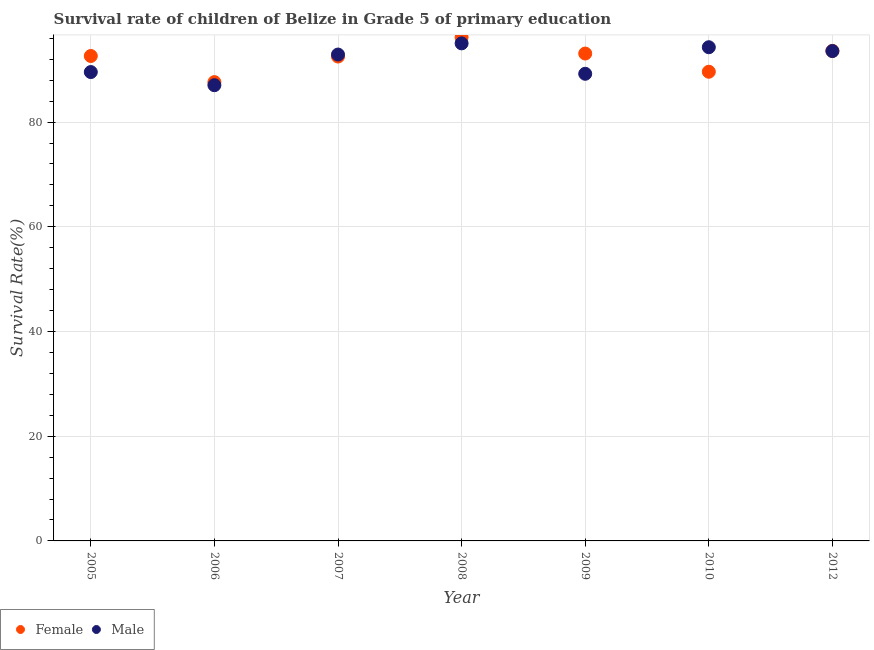Is the number of dotlines equal to the number of legend labels?
Keep it short and to the point. Yes. What is the survival rate of female students in primary education in 2005?
Provide a succinct answer. 92.62. Across all years, what is the maximum survival rate of male students in primary education?
Ensure brevity in your answer.  95.03. Across all years, what is the minimum survival rate of male students in primary education?
Provide a short and direct response. 87.04. In which year was the survival rate of female students in primary education minimum?
Provide a succinct answer. 2006. What is the total survival rate of male students in primary education in the graph?
Your answer should be very brief. 641.59. What is the difference between the survival rate of male students in primary education in 2005 and that in 2010?
Provide a succinct answer. -4.74. What is the difference between the survival rate of female students in primary education in 2005 and the survival rate of male students in primary education in 2009?
Provide a succinct answer. 3.4. What is the average survival rate of female students in primary education per year?
Keep it short and to the point. 92.18. In the year 2005, what is the difference between the survival rate of male students in primary education and survival rate of female students in primary education?
Give a very brief answer. -3.07. In how many years, is the survival rate of male students in primary education greater than 80 %?
Offer a terse response. 7. What is the ratio of the survival rate of female students in primary education in 2007 to that in 2012?
Make the answer very short. 0.99. Is the survival rate of female students in primary education in 2008 less than that in 2010?
Provide a short and direct response. No. Is the difference between the survival rate of female students in primary education in 2005 and 2010 greater than the difference between the survival rate of male students in primary education in 2005 and 2010?
Provide a short and direct response. Yes. What is the difference between the highest and the second highest survival rate of female students in primary education?
Provide a short and direct response. 2.6. What is the difference between the highest and the lowest survival rate of male students in primary education?
Provide a short and direct response. 7.99. In how many years, is the survival rate of female students in primary education greater than the average survival rate of female students in primary education taken over all years?
Ensure brevity in your answer.  5. Is the sum of the survival rate of female students in primary education in 2005 and 2009 greater than the maximum survival rate of male students in primary education across all years?
Offer a terse response. Yes. Does the survival rate of male students in primary education monotonically increase over the years?
Your answer should be compact. No. Is the survival rate of male students in primary education strictly greater than the survival rate of female students in primary education over the years?
Provide a short and direct response. No. How many dotlines are there?
Provide a succinct answer. 2. How many years are there in the graph?
Ensure brevity in your answer.  7. Where does the legend appear in the graph?
Your response must be concise. Bottom left. How many legend labels are there?
Provide a succinct answer. 2. What is the title of the graph?
Your answer should be very brief. Survival rate of children of Belize in Grade 5 of primary education. Does "Money lenders" appear as one of the legend labels in the graph?
Your response must be concise. No. What is the label or title of the X-axis?
Offer a terse response. Year. What is the label or title of the Y-axis?
Make the answer very short. Survival Rate(%). What is the Survival Rate(%) in Female in 2005?
Keep it short and to the point. 92.62. What is the Survival Rate(%) in Male in 2005?
Provide a succinct answer. 89.55. What is the Survival Rate(%) in Female in 2006?
Make the answer very short. 87.63. What is the Survival Rate(%) of Male in 2006?
Your answer should be compact. 87.04. What is the Survival Rate(%) in Female in 2007?
Provide a short and direct response. 92.51. What is the Survival Rate(%) of Male in 2007?
Your answer should be compact. 92.9. What is the Survival Rate(%) of Female in 2008?
Your answer should be very brief. 96.19. What is the Survival Rate(%) in Male in 2008?
Offer a very short reply. 95.03. What is the Survival Rate(%) of Female in 2009?
Your answer should be compact. 93.09. What is the Survival Rate(%) of Male in 2009?
Offer a very short reply. 89.22. What is the Survival Rate(%) of Female in 2010?
Your response must be concise. 89.61. What is the Survival Rate(%) in Male in 2010?
Offer a terse response. 94.29. What is the Survival Rate(%) in Female in 2012?
Give a very brief answer. 93.59. What is the Survival Rate(%) in Male in 2012?
Keep it short and to the point. 93.56. Across all years, what is the maximum Survival Rate(%) in Female?
Give a very brief answer. 96.19. Across all years, what is the maximum Survival Rate(%) of Male?
Your answer should be very brief. 95.03. Across all years, what is the minimum Survival Rate(%) in Female?
Offer a very short reply. 87.63. Across all years, what is the minimum Survival Rate(%) of Male?
Your answer should be very brief. 87.04. What is the total Survival Rate(%) in Female in the graph?
Provide a short and direct response. 645.24. What is the total Survival Rate(%) in Male in the graph?
Offer a terse response. 641.59. What is the difference between the Survival Rate(%) in Female in 2005 and that in 2006?
Offer a very short reply. 4.99. What is the difference between the Survival Rate(%) of Male in 2005 and that in 2006?
Keep it short and to the point. 2.51. What is the difference between the Survival Rate(%) in Female in 2005 and that in 2007?
Your answer should be compact. 0.1. What is the difference between the Survival Rate(%) of Male in 2005 and that in 2007?
Offer a terse response. -3.35. What is the difference between the Survival Rate(%) of Female in 2005 and that in 2008?
Your response must be concise. -3.58. What is the difference between the Survival Rate(%) of Male in 2005 and that in 2008?
Offer a terse response. -5.48. What is the difference between the Survival Rate(%) of Female in 2005 and that in 2009?
Give a very brief answer. -0.47. What is the difference between the Survival Rate(%) in Male in 2005 and that in 2009?
Offer a terse response. 0.33. What is the difference between the Survival Rate(%) in Female in 2005 and that in 2010?
Give a very brief answer. 3.01. What is the difference between the Survival Rate(%) in Male in 2005 and that in 2010?
Give a very brief answer. -4.74. What is the difference between the Survival Rate(%) in Female in 2005 and that in 2012?
Offer a very short reply. -0.97. What is the difference between the Survival Rate(%) of Male in 2005 and that in 2012?
Keep it short and to the point. -4.01. What is the difference between the Survival Rate(%) of Female in 2006 and that in 2007?
Offer a very short reply. -4.89. What is the difference between the Survival Rate(%) of Male in 2006 and that in 2007?
Provide a succinct answer. -5.85. What is the difference between the Survival Rate(%) in Female in 2006 and that in 2008?
Your answer should be compact. -8.56. What is the difference between the Survival Rate(%) of Male in 2006 and that in 2008?
Your answer should be compact. -7.99. What is the difference between the Survival Rate(%) in Female in 2006 and that in 2009?
Offer a very short reply. -5.46. What is the difference between the Survival Rate(%) of Male in 2006 and that in 2009?
Make the answer very short. -2.18. What is the difference between the Survival Rate(%) of Female in 2006 and that in 2010?
Offer a very short reply. -1.98. What is the difference between the Survival Rate(%) of Male in 2006 and that in 2010?
Offer a very short reply. -7.25. What is the difference between the Survival Rate(%) in Female in 2006 and that in 2012?
Your answer should be compact. -5.96. What is the difference between the Survival Rate(%) of Male in 2006 and that in 2012?
Ensure brevity in your answer.  -6.52. What is the difference between the Survival Rate(%) of Female in 2007 and that in 2008?
Provide a succinct answer. -3.68. What is the difference between the Survival Rate(%) in Male in 2007 and that in 2008?
Offer a very short reply. -2.13. What is the difference between the Survival Rate(%) of Female in 2007 and that in 2009?
Give a very brief answer. -0.57. What is the difference between the Survival Rate(%) in Male in 2007 and that in 2009?
Your answer should be very brief. 3.68. What is the difference between the Survival Rate(%) of Female in 2007 and that in 2010?
Your response must be concise. 2.91. What is the difference between the Survival Rate(%) of Male in 2007 and that in 2010?
Offer a very short reply. -1.4. What is the difference between the Survival Rate(%) in Female in 2007 and that in 2012?
Your answer should be very brief. -1.08. What is the difference between the Survival Rate(%) of Male in 2007 and that in 2012?
Keep it short and to the point. -0.67. What is the difference between the Survival Rate(%) in Female in 2008 and that in 2009?
Provide a short and direct response. 3.11. What is the difference between the Survival Rate(%) of Male in 2008 and that in 2009?
Provide a succinct answer. 5.81. What is the difference between the Survival Rate(%) of Female in 2008 and that in 2010?
Ensure brevity in your answer.  6.58. What is the difference between the Survival Rate(%) of Male in 2008 and that in 2010?
Provide a short and direct response. 0.74. What is the difference between the Survival Rate(%) in Female in 2008 and that in 2012?
Offer a very short reply. 2.6. What is the difference between the Survival Rate(%) in Male in 2008 and that in 2012?
Your answer should be compact. 1.47. What is the difference between the Survival Rate(%) in Female in 2009 and that in 2010?
Your answer should be very brief. 3.48. What is the difference between the Survival Rate(%) in Male in 2009 and that in 2010?
Your response must be concise. -5.07. What is the difference between the Survival Rate(%) in Female in 2009 and that in 2012?
Ensure brevity in your answer.  -0.5. What is the difference between the Survival Rate(%) in Male in 2009 and that in 2012?
Keep it short and to the point. -4.34. What is the difference between the Survival Rate(%) in Female in 2010 and that in 2012?
Offer a terse response. -3.98. What is the difference between the Survival Rate(%) in Male in 2010 and that in 2012?
Make the answer very short. 0.73. What is the difference between the Survival Rate(%) of Female in 2005 and the Survival Rate(%) of Male in 2006?
Keep it short and to the point. 5.58. What is the difference between the Survival Rate(%) in Female in 2005 and the Survival Rate(%) in Male in 2007?
Make the answer very short. -0.28. What is the difference between the Survival Rate(%) of Female in 2005 and the Survival Rate(%) of Male in 2008?
Provide a succinct answer. -2.41. What is the difference between the Survival Rate(%) of Female in 2005 and the Survival Rate(%) of Male in 2009?
Offer a very short reply. 3.4. What is the difference between the Survival Rate(%) in Female in 2005 and the Survival Rate(%) in Male in 2010?
Provide a short and direct response. -1.67. What is the difference between the Survival Rate(%) in Female in 2005 and the Survival Rate(%) in Male in 2012?
Offer a terse response. -0.94. What is the difference between the Survival Rate(%) in Female in 2006 and the Survival Rate(%) in Male in 2007?
Your answer should be very brief. -5.27. What is the difference between the Survival Rate(%) in Female in 2006 and the Survival Rate(%) in Male in 2008?
Provide a short and direct response. -7.4. What is the difference between the Survival Rate(%) in Female in 2006 and the Survival Rate(%) in Male in 2009?
Your response must be concise. -1.59. What is the difference between the Survival Rate(%) of Female in 2006 and the Survival Rate(%) of Male in 2010?
Provide a succinct answer. -6.66. What is the difference between the Survival Rate(%) in Female in 2006 and the Survival Rate(%) in Male in 2012?
Provide a short and direct response. -5.93. What is the difference between the Survival Rate(%) of Female in 2007 and the Survival Rate(%) of Male in 2008?
Your response must be concise. -2.52. What is the difference between the Survival Rate(%) of Female in 2007 and the Survival Rate(%) of Male in 2009?
Provide a short and direct response. 3.29. What is the difference between the Survival Rate(%) in Female in 2007 and the Survival Rate(%) in Male in 2010?
Provide a short and direct response. -1.78. What is the difference between the Survival Rate(%) of Female in 2007 and the Survival Rate(%) of Male in 2012?
Your response must be concise. -1.05. What is the difference between the Survival Rate(%) in Female in 2008 and the Survival Rate(%) in Male in 2009?
Your response must be concise. 6.97. What is the difference between the Survival Rate(%) in Female in 2008 and the Survival Rate(%) in Male in 2010?
Make the answer very short. 1.9. What is the difference between the Survival Rate(%) of Female in 2008 and the Survival Rate(%) of Male in 2012?
Offer a very short reply. 2.63. What is the difference between the Survival Rate(%) in Female in 2009 and the Survival Rate(%) in Male in 2010?
Offer a very short reply. -1.2. What is the difference between the Survival Rate(%) of Female in 2009 and the Survival Rate(%) of Male in 2012?
Provide a succinct answer. -0.47. What is the difference between the Survival Rate(%) in Female in 2010 and the Survival Rate(%) in Male in 2012?
Ensure brevity in your answer.  -3.95. What is the average Survival Rate(%) in Female per year?
Offer a very short reply. 92.18. What is the average Survival Rate(%) of Male per year?
Give a very brief answer. 91.66. In the year 2005, what is the difference between the Survival Rate(%) in Female and Survival Rate(%) in Male?
Your response must be concise. 3.07. In the year 2006, what is the difference between the Survival Rate(%) in Female and Survival Rate(%) in Male?
Your answer should be compact. 0.59. In the year 2007, what is the difference between the Survival Rate(%) in Female and Survival Rate(%) in Male?
Offer a terse response. -0.38. In the year 2008, what is the difference between the Survival Rate(%) in Female and Survival Rate(%) in Male?
Keep it short and to the point. 1.16. In the year 2009, what is the difference between the Survival Rate(%) in Female and Survival Rate(%) in Male?
Your response must be concise. 3.87. In the year 2010, what is the difference between the Survival Rate(%) of Female and Survival Rate(%) of Male?
Give a very brief answer. -4.68. In the year 2012, what is the difference between the Survival Rate(%) of Female and Survival Rate(%) of Male?
Your response must be concise. 0.03. What is the ratio of the Survival Rate(%) of Female in 2005 to that in 2006?
Keep it short and to the point. 1.06. What is the ratio of the Survival Rate(%) of Male in 2005 to that in 2006?
Your response must be concise. 1.03. What is the ratio of the Survival Rate(%) of Male in 2005 to that in 2007?
Make the answer very short. 0.96. What is the ratio of the Survival Rate(%) of Female in 2005 to that in 2008?
Give a very brief answer. 0.96. What is the ratio of the Survival Rate(%) in Male in 2005 to that in 2008?
Offer a very short reply. 0.94. What is the ratio of the Survival Rate(%) in Female in 2005 to that in 2010?
Your answer should be very brief. 1.03. What is the ratio of the Survival Rate(%) in Male in 2005 to that in 2010?
Your answer should be compact. 0.95. What is the ratio of the Survival Rate(%) in Male in 2005 to that in 2012?
Provide a succinct answer. 0.96. What is the ratio of the Survival Rate(%) in Female in 2006 to that in 2007?
Offer a very short reply. 0.95. What is the ratio of the Survival Rate(%) in Male in 2006 to that in 2007?
Your response must be concise. 0.94. What is the ratio of the Survival Rate(%) in Female in 2006 to that in 2008?
Give a very brief answer. 0.91. What is the ratio of the Survival Rate(%) in Male in 2006 to that in 2008?
Keep it short and to the point. 0.92. What is the ratio of the Survival Rate(%) in Female in 2006 to that in 2009?
Keep it short and to the point. 0.94. What is the ratio of the Survival Rate(%) of Male in 2006 to that in 2009?
Provide a short and direct response. 0.98. What is the ratio of the Survival Rate(%) of Female in 2006 to that in 2010?
Your response must be concise. 0.98. What is the ratio of the Survival Rate(%) of Female in 2006 to that in 2012?
Provide a short and direct response. 0.94. What is the ratio of the Survival Rate(%) in Male in 2006 to that in 2012?
Keep it short and to the point. 0.93. What is the ratio of the Survival Rate(%) in Female in 2007 to that in 2008?
Keep it short and to the point. 0.96. What is the ratio of the Survival Rate(%) in Male in 2007 to that in 2008?
Ensure brevity in your answer.  0.98. What is the ratio of the Survival Rate(%) of Female in 2007 to that in 2009?
Offer a terse response. 0.99. What is the ratio of the Survival Rate(%) of Male in 2007 to that in 2009?
Offer a terse response. 1.04. What is the ratio of the Survival Rate(%) of Female in 2007 to that in 2010?
Provide a succinct answer. 1.03. What is the ratio of the Survival Rate(%) in Male in 2007 to that in 2010?
Your answer should be very brief. 0.99. What is the ratio of the Survival Rate(%) in Female in 2007 to that in 2012?
Make the answer very short. 0.99. What is the ratio of the Survival Rate(%) in Female in 2008 to that in 2009?
Make the answer very short. 1.03. What is the ratio of the Survival Rate(%) in Male in 2008 to that in 2009?
Your answer should be compact. 1.07. What is the ratio of the Survival Rate(%) in Female in 2008 to that in 2010?
Your answer should be compact. 1.07. What is the ratio of the Survival Rate(%) in Male in 2008 to that in 2010?
Offer a terse response. 1.01. What is the ratio of the Survival Rate(%) of Female in 2008 to that in 2012?
Your answer should be compact. 1.03. What is the ratio of the Survival Rate(%) of Male in 2008 to that in 2012?
Offer a very short reply. 1.02. What is the ratio of the Survival Rate(%) in Female in 2009 to that in 2010?
Your answer should be compact. 1.04. What is the ratio of the Survival Rate(%) of Male in 2009 to that in 2010?
Offer a very short reply. 0.95. What is the ratio of the Survival Rate(%) in Female in 2009 to that in 2012?
Provide a short and direct response. 0.99. What is the ratio of the Survival Rate(%) in Male in 2009 to that in 2012?
Your answer should be very brief. 0.95. What is the ratio of the Survival Rate(%) of Female in 2010 to that in 2012?
Offer a terse response. 0.96. What is the ratio of the Survival Rate(%) in Male in 2010 to that in 2012?
Your answer should be very brief. 1.01. What is the difference between the highest and the second highest Survival Rate(%) in Female?
Your answer should be very brief. 2.6. What is the difference between the highest and the second highest Survival Rate(%) of Male?
Keep it short and to the point. 0.74. What is the difference between the highest and the lowest Survival Rate(%) of Female?
Your answer should be very brief. 8.56. What is the difference between the highest and the lowest Survival Rate(%) in Male?
Your answer should be compact. 7.99. 